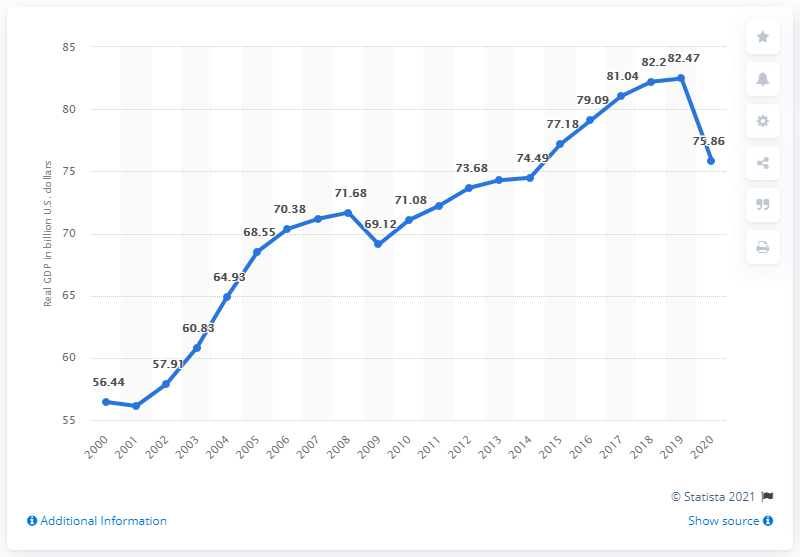Indicate a few pertinent items in this graphic. Hawaii's Gross Domestic Product (GDP) in the previous year was 82.47 billion dollars. In 2020, the Gross Domestic Product (GDP) of Hawaii was 75.86. 